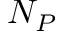<formula> <loc_0><loc_0><loc_500><loc_500>N _ { P }</formula> 